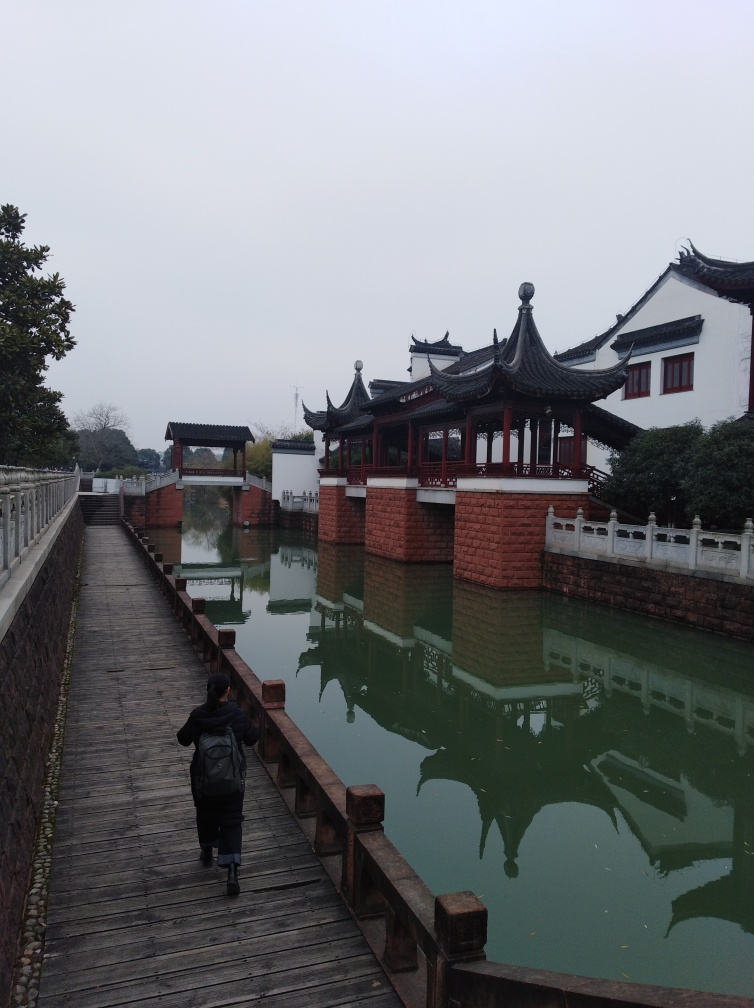Can you tell me about the architectural style visible in the image? The architecture seen in the image reflects traditional East Asian influences, identifiable by the sweeping curves of the pagoda-style rooftops, upturned eaves, and ornamental ridge crests. The white walls with dark tiles are typical of historical buildings found in places like China, representing a style that harmonizes with the natural environment. 